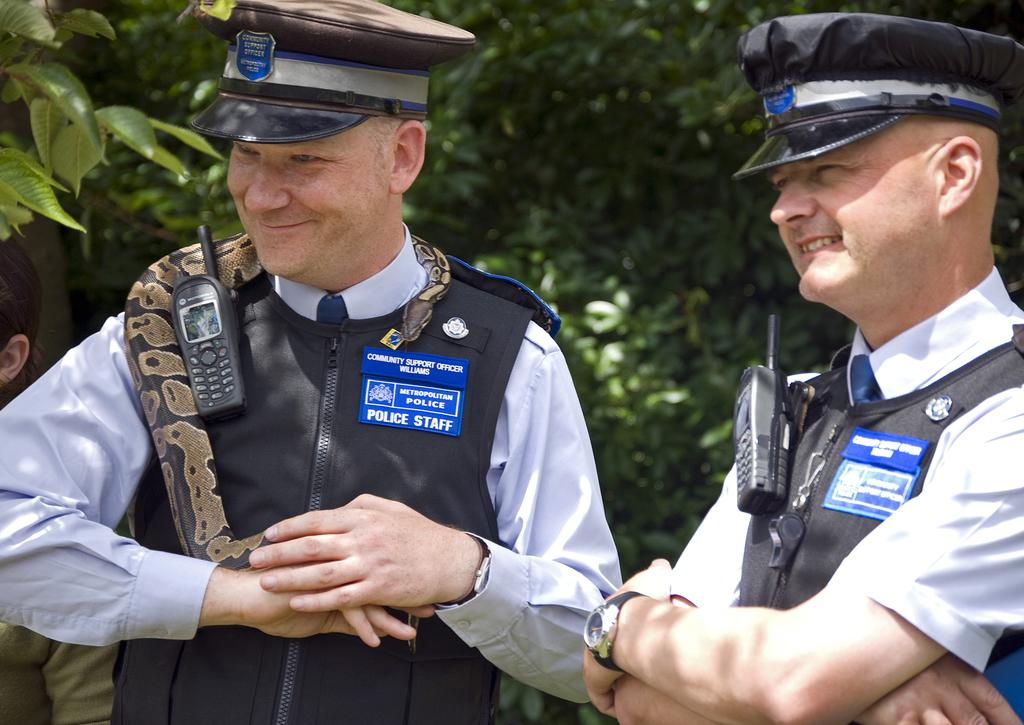Provide a one-sentence caption for the provided image. Two men are wearing blue metropolitan police badges. 